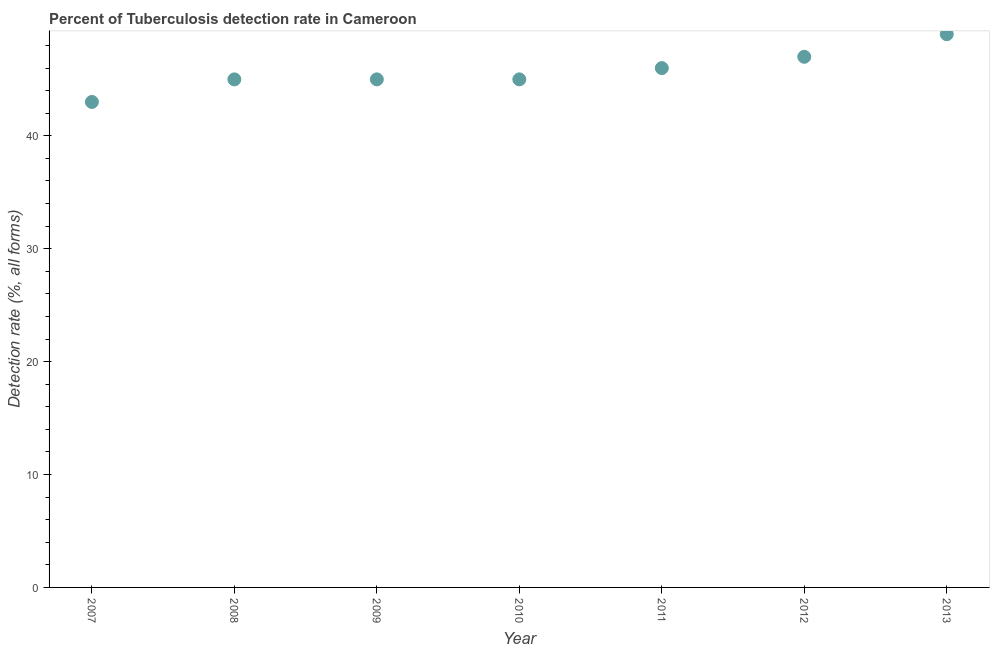What is the detection rate of tuberculosis in 2009?
Ensure brevity in your answer.  45. Across all years, what is the maximum detection rate of tuberculosis?
Give a very brief answer. 49. What is the sum of the detection rate of tuberculosis?
Provide a short and direct response. 320. What is the average detection rate of tuberculosis per year?
Your answer should be compact. 45.71. In how many years, is the detection rate of tuberculosis greater than 16 %?
Provide a succinct answer. 7. What is the ratio of the detection rate of tuberculosis in 2011 to that in 2012?
Provide a succinct answer. 0.98. In how many years, is the detection rate of tuberculosis greater than the average detection rate of tuberculosis taken over all years?
Provide a short and direct response. 3. Does the detection rate of tuberculosis monotonically increase over the years?
Ensure brevity in your answer.  No. How many dotlines are there?
Offer a very short reply. 1. What is the difference between two consecutive major ticks on the Y-axis?
Your response must be concise. 10. Are the values on the major ticks of Y-axis written in scientific E-notation?
Your answer should be compact. No. Does the graph contain any zero values?
Provide a succinct answer. No. Does the graph contain grids?
Your response must be concise. No. What is the title of the graph?
Provide a succinct answer. Percent of Tuberculosis detection rate in Cameroon. What is the label or title of the Y-axis?
Ensure brevity in your answer.  Detection rate (%, all forms). What is the Detection rate (%, all forms) in 2007?
Provide a short and direct response. 43. What is the Detection rate (%, all forms) in 2008?
Offer a very short reply. 45. What is the Detection rate (%, all forms) in 2009?
Your answer should be compact. 45. What is the Detection rate (%, all forms) in 2012?
Offer a very short reply. 47. What is the difference between the Detection rate (%, all forms) in 2007 and 2009?
Your answer should be compact. -2. What is the difference between the Detection rate (%, all forms) in 2007 and 2010?
Your response must be concise. -2. What is the difference between the Detection rate (%, all forms) in 2007 and 2012?
Make the answer very short. -4. What is the difference between the Detection rate (%, all forms) in 2007 and 2013?
Provide a short and direct response. -6. What is the difference between the Detection rate (%, all forms) in 2008 and 2010?
Provide a succinct answer. 0. What is the difference between the Detection rate (%, all forms) in 2008 and 2011?
Provide a short and direct response. -1. What is the difference between the Detection rate (%, all forms) in 2008 and 2012?
Offer a very short reply. -2. What is the difference between the Detection rate (%, all forms) in 2009 and 2010?
Offer a terse response. 0. What is the difference between the Detection rate (%, all forms) in 2009 and 2012?
Your answer should be compact. -2. What is the difference between the Detection rate (%, all forms) in 2009 and 2013?
Your answer should be compact. -4. What is the difference between the Detection rate (%, all forms) in 2010 and 2011?
Your answer should be compact. -1. What is the difference between the Detection rate (%, all forms) in 2012 and 2013?
Keep it short and to the point. -2. What is the ratio of the Detection rate (%, all forms) in 2007 to that in 2008?
Offer a terse response. 0.96. What is the ratio of the Detection rate (%, all forms) in 2007 to that in 2009?
Your response must be concise. 0.96. What is the ratio of the Detection rate (%, all forms) in 2007 to that in 2010?
Keep it short and to the point. 0.96. What is the ratio of the Detection rate (%, all forms) in 2007 to that in 2011?
Provide a succinct answer. 0.94. What is the ratio of the Detection rate (%, all forms) in 2007 to that in 2012?
Offer a terse response. 0.92. What is the ratio of the Detection rate (%, all forms) in 2007 to that in 2013?
Give a very brief answer. 0.88. What is the ratio of the Detection rate (%, all forms) in 2008 to that in 2012?
Provide a short and direct response. 0.96. What is the ratio of the Detection rate (%, all forms) in 2008 to that in 2013?
Offer a terse response. 0.92. What is the ratio of the Detection rate (%, all forms) in 2009 to that in 2011?
Your answer should be very brief. 0.98. What is the ratio of the Detection rate (%, all forms) in 2009 to that in 2012?
Provide a succinct answer. 0.96. What is the ratio of the Detection rate (%, all forms) in 2009 to that in 2013?
Offer a very short reply. 0.92. What is the ratio of the Detection rate (%, all forms) in 2010 to that in 2012?
Offer a terse response. 0.96. What is the ratio of the Detection rate (%, all forms) in 2010 to that in 2013?
Provide a short and direct response. 0.92. What is the ratio of the Detection rate (%, all forms) in 2011 to that in 2012?
Offer a terse response. 0.98. What is the ratio of the Detection rate (%, all forms) in 2011 to that in 2013?
Ensure brevity in your answer.  0.94. 